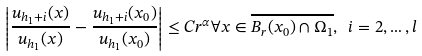<formula> <loc_0><loc_0><loc_500><loc_500>\left | \frac { u _ { h _ { 1 } + i } ( x ) } { u _ { h _ { 1 } } ( x ) } - \frac { u _ { h _ { 1 } + i } ( x _ { 0 } ) } { u _ { h _ { 1 } } ( x _ { 0 } ) } \right | \leq C r ^ { \alpha } \forall x \in \overline { B _ { r } ( x _ { 0 } ) \cap \Omega _ { 1 } } , \ i = 2 , \dots , l</formula> 